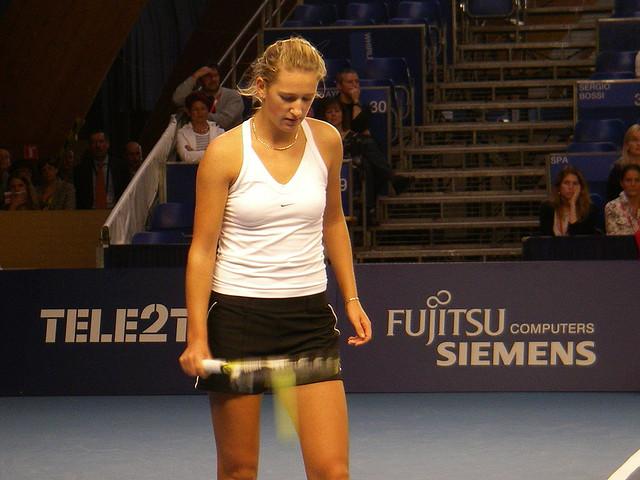What kind of computers are advertised?
Answer briefly. Fujitsu. Is the player wearing any jewelry?
Give a very brief answer. Yes. What color is her shirt?
Be succinct. White. Is this woman laughing?
Give a very brief answer. No. 